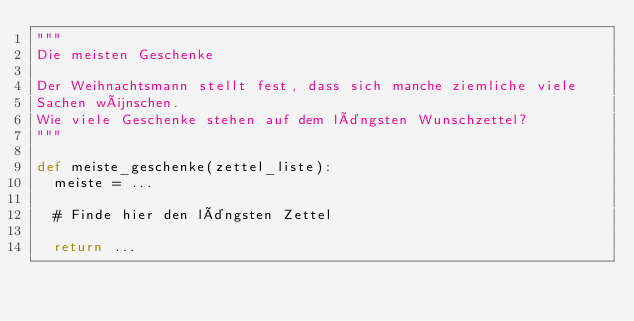<code> <loc_0><loc_0><loc_500><loc_500><_Python_>"""
Die meisten Geschenke

Der Weihnachtsmann stellt fest, dass sich manche ziemliche viele
Sachen wünschen.
Wie viele Geschenke stehen auf dem längsten Wunschzettel?
"""

def meiste_geschenke(zettel_liste):
  meiste = ...

  # Finde hier den längsten Zettel

  return ...
</code> 